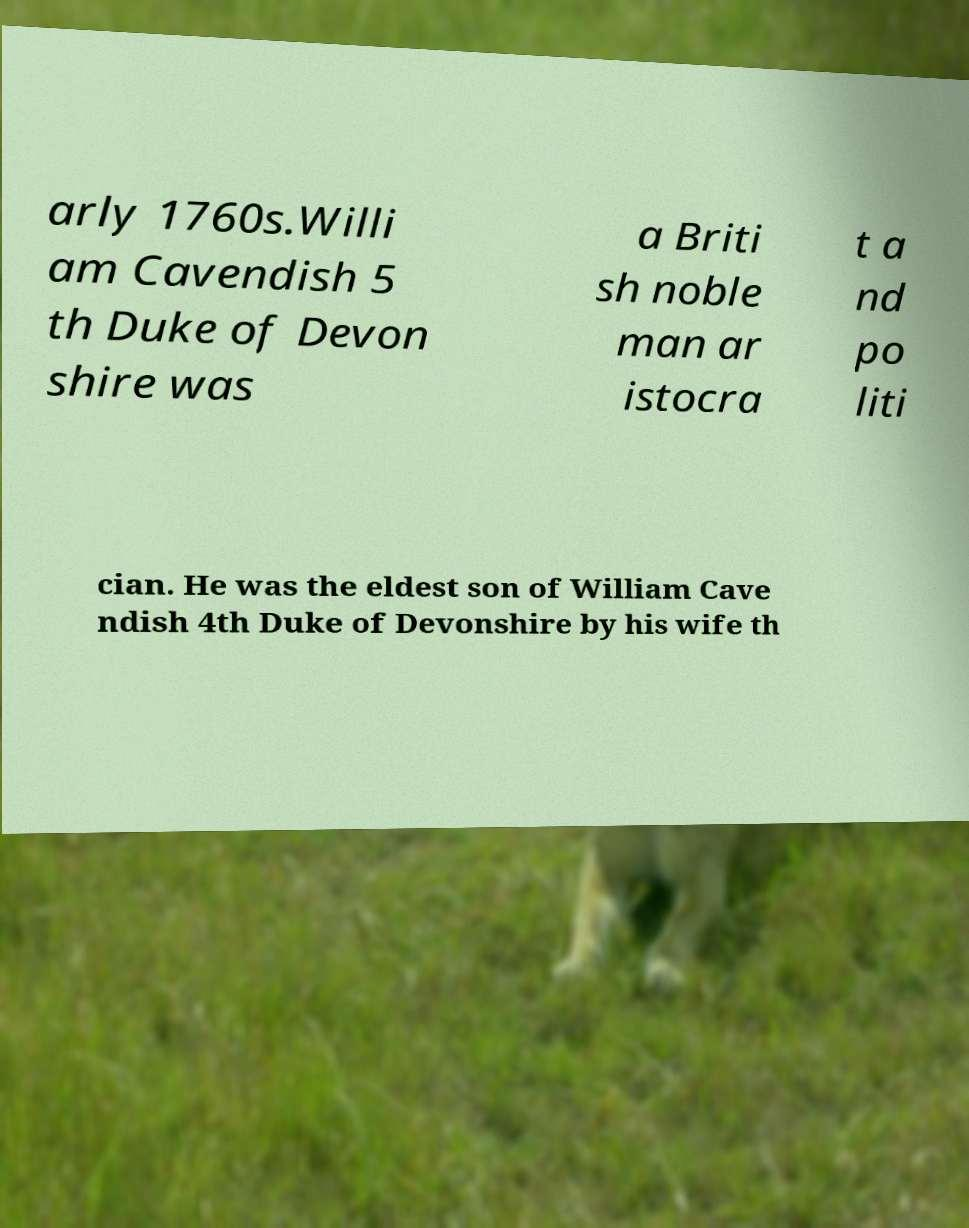Could you assist in decoding the text presented in this image and type it out clearly? arly 1760s.Willi am Cavendish 5 th Duke of Devon shire was a Briti sh noble man ar istocra t a nd po liti cian. He was the eldest son of William Cave ndish 4th Duke of Devonshire by his wife th 